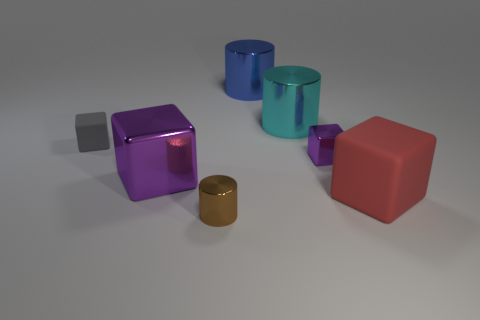Subtract all gray cylinders. How many purple blocks are left? 2 Subtract all big shiny cylinders. How many cylinders are left? 1 Subtract 1 blocks. How many blocks are left? 3 Subtract all brown blocks. Subtract all brown cylinders. How many blocks are left? 4 Add 1 small shiny things. How many objects exist? 8 Subtract all cylinders. How many objects are left? 4 Add 7 tiny cylinders. How many tiny cylinders are left? 8 Add 1 tiny purple metallic cubes. How many tiny purple metallic cubes exist? 2 Subtract 0 green balls. How many objects are left? 7 Subtract all blue objects. Subtract all large blue shiny objects. How many objects are left? 5 